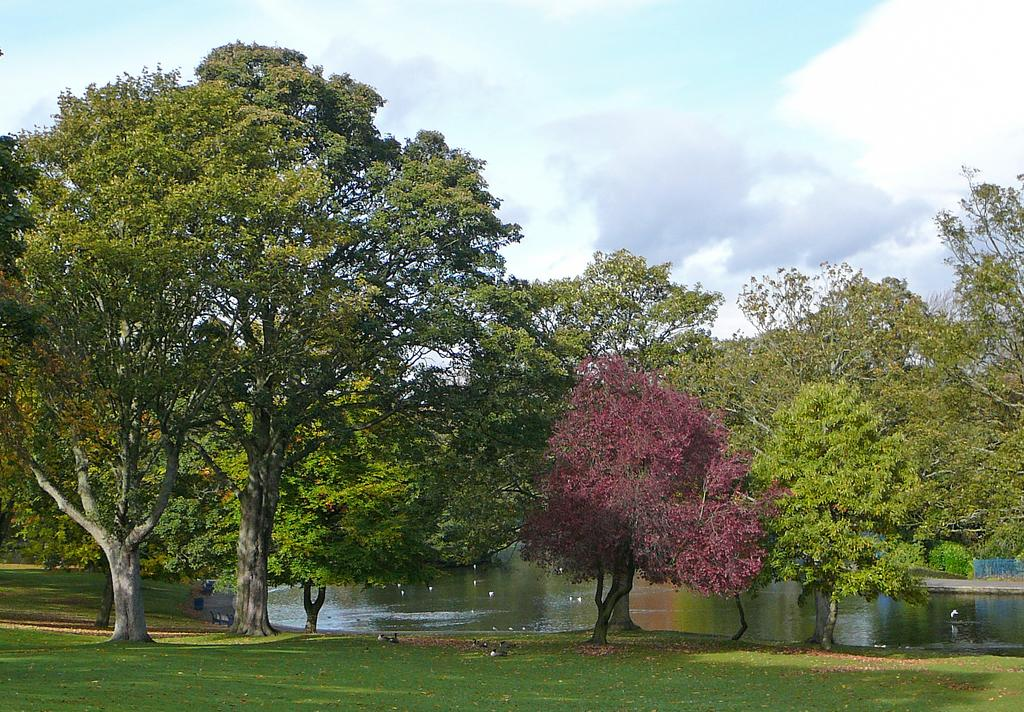What type of vegetation is present on the ground in the image? There is grass on the ground in the front of the image. What can be seen in the background of the image? There are trees in the background of the image. What is the water feature in the image? The water is visible in the image. How would you describe the sky in the image? The sky is cloudy in the image. Can you see a parcel floating on the water in the image? There is no parcel visible in the image; it only features grass, trees, water, and a cloudy sky. What type of crack is present on the face of the person in the image? There is no person or face present in the image; it only features grass, trees, water, and a cloudy sky. 